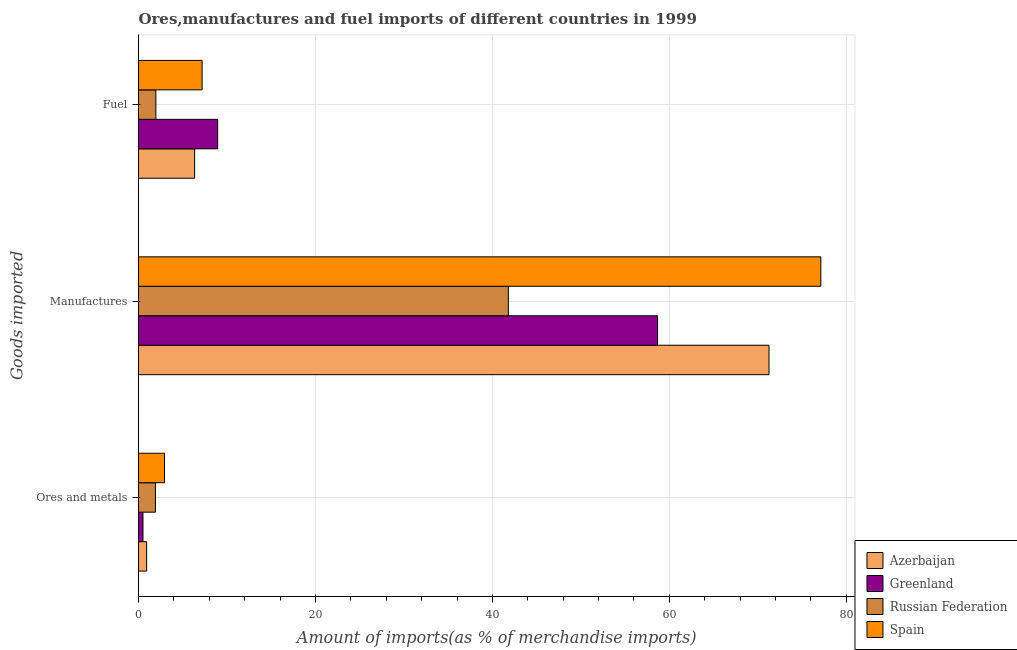How many bars are there on the 3rd tick from the top?
Your answer should be very brief. 4. What is the label of the 2nd group of bars from the top?
Your response must be concise. Manufactures. What is the percentage of fuel imports in Russian Federation?
Ensure brevity in your answer.  1.96. Across all countries, what is the maximum percentage of manufactures imports?
Keep it short and to the point. 77.12. Across all countries, what is the minimum percentage of manufactures imports?
Your answer should be very brief. 41.8. In which country was the percentage of fuel imports minimum?
Ensure brevity in your answer.  Russian Federation. What is the total percentage of fuel imports in the graph?
Offer a very short reply. 24.44. What is the difference between the percentage of fuel imports in Spain and that in Russian Federation?
Make the answer very short. 5.23. What is the difference between the percentage of fuel imports in Greenland and the percentage of ores and metals imports in Azerbaijan?
Your response must be concise. 8.03. What is the average percentage of fuel imports per country?
Your response must be concise. 6.11. What is the difference between the percentage of fuel imports and percentage of manufactures imports in Russian Federation?
Ensure brevity in your answer.  -39.84. In how many countries, is the percentage of fuel imports greater than 48 %?
Your answer should be compact. 0. What is the ratio of the percentage of manufactures imports in Russian Federation to that in Azerbaijan?
Your response must be concise. 0.59. Is the percentage of manufactures imports in Spain less than that in Greenland?
Your answer should be compact. No. Is the difference between the percentage of manufactures imports in Greenland and Russian Federation greater than the difference between the percentage of ores and metals imports in Greenland and Russian Federation?
Offer a very short reply. Yes. What is the difference between the highest and the second highest percentage of ores and metals imports?
Provide a succinct answer. 1.03. What is the difference between the highest and the lowest percentage of ores and metals imports?
Offer a very short reply. 2.44. Is the sum of the percentage of ores and metals imports in Azerbaijan and Greenland greater than the maximum percentage of manufactures imports across all countries?
Ensure brevity in your answer.  No. What does the 4th bar from the top in Manufactures represents?
Provide a short and direct response. Azerbaijan. What does the 1st bar from the bottom in Fuel represents?
Provide a short and direct response. Azerbaijan. Is it the case that in every country, the sum of the percentage of ores and metals imports and percentage of manufactures imports is greater than the percentage of fuel imports?
Provide a short and direct response. Yes. How many countries are there in the graph?
Your response must be concise. 4. Does the graph contain grids?
Your answer should be very brief. Yes. Where does the legend appear in the graph?
Provide a short and direct response. Bottom right. What is the title of the graph?
Your answer should be compact. Ores,manufactures and fuel imports of different countries in 1999. Does "Swaziland" appear as one of the legend labels in the graph?
Make the answer very short. No. What is the label or title of the X-axis?
Keep it short and to the point. Amount of imports(as % of merchandise imports). What is the label or title of the Y-axis?
Ensure brevity in your answer.  Goods imported. What is the Amount of imports(as % of merchandise imports) of Azerbaijan in Ores and metals?
Your response must be concise. 0.92. What is the Amount of imports(as % of merchandise imports) of Greenland in Ores and metals?
Make the answer very short. 0.5. What is the Amount of imports(as % of merchandise imports) of Russian Federation in Ores and metals?
Offer a terse response. 1.91. What is the Amount of imports(as % of merchandise imports) of Spain in Ores and metals?
Offer a terse response. 2.94. What is the Amount of imports(as % of merchandise imports) of Azerbaijan in Manufactures?
Provide a short and direct response. 71.26. What is the Amount of imports(as % of merchandise imports) in Greenland in Manufactures?
Keep it short and to the point. 58.67. What is the Amount of imports(as % of merchandise imports) of Russian Federation in Manufactures?
Keep it short and to the point. 41.8. What is the Amount of imports(as % of merchandise imports) of Spain in Manufactures?
Your response must be concise. 77.12. What is the Amount of imports(as % of merchandise imports) of Azerbaijan in Fuel?
Ensure brevity in your answer.  6.34. What is the Amount of imports(as % of merchandise imports) in Greenland in Fuel?
Give a very brief answer. 8.95. What is the Amount of imports(as % of merchandise imports) of Russian Federation in Fuel?
Your response must be concise. 1.96. What is the Amount of imports(as % of merchandise imports) of Spain in Fuel?
Make the answer very short. 7.19. Across all Goods imported, what is the maximum Amount of imports(as % of merchandise imports) of Azerbaijan?
Your response must be concise. 71.26. Across all Goods imported, what is the maximum Amount of imports(as % of merchandise imports) in Greenland?
Your answer should be very brief. 58.67. Across all Goods imported, what is the maximum Amount of imports(as % of merchandise imports) of Russian Federation?
Keep it short and to the point. 41.8. Across all Goods imported, what is the maximum Amount of imports(as % of merchandise imports) of Spain?
Provide a succinct answer. 77.12. Across all Goods imported, what is the minimum Amount of imports(as % of merchandise imports) in Azerbaijan?
Your answer should be very brief. 0.92. Across all Goods imported, what is the minimum Amount of imports(as % of merchandise imports) in Greenland?
Offer a terse response. 0.5. Across all Goods imported, what is the minimum Amount of imports(as % of merchandise imports) of Russian Federation?
Provide a short and direct response. 1.91. Across all Goods imported, what is the minimum Amount of imports(as % of merchandise imports) of Spain?
Your answer should be very brief. 2.94. What is the total Amount of imports(as % of merchandise imports) of Azerbaijan in the graph?
Ensure brevity in your answer.  78.52. What is the total Amount of imports(as % of merchandise imports) of Greenland in the graph?
Offer a very short reply. 68.12. What is the total Amount of imports(as % of merchandise imports) of Russian Federation in the graph?
Offer a terse response. 45.68. What is the total Amount of imports(as % of merchandise imports) in Spain in the graph?
Provide a succinct answer. 87.25. What is the difference between the Amount of imports(as % of merchandise imports) of Azerbaijan in Ores and metals and that in Manufactures?
Give a very brief answer. -70.34. What is the difference between the Amount of imports(as % of merchandise imports) in Greenland in Ores and metals and that in Manufactures?
Your response must be concise. -58.16. What is the difference between the Amount of imports(as % of merchandise imports) of Russian Federation in Ores and metals and that in Manufactures?
Your answer should be compact. -39.89. What is the difference between the Amount of imports(as % of merchandise imports) in Spain in Ores and metals and that in Manufactures?
Give a very brief answer. -74.18. What is the difference between the Amount of imports(as % of merchandise imports) in Azerbaijan in Ores and metals and that in Fuel?
Your answer should be compact. -5.42. What is the difference between the Amount of imports(as % of merchandise imports) in Greenland in Ores and metals and that in Fuel?
Your answer should be very brief. -8.44. What is the difference between the Amount of imports(as % of merchandise imports) in Russian Federation in Ores and metals and that in Fuel?
Provide a succinct answer. -0.05. What is the difference between the Amount of imports(as % of merchandise imports) in Spain in Ores and metals and that in Fuel?
Make the answer very short. -4.25. What is the difference between the Amount of imports(as % of merchandise imports) in Azerbaijan in Manufactures and that in Fuel?
Your response must be concise. 64.92. What is the difference between the Amount of imports(as % of merchandise imports) of Greenland in Manufactures and that in Fuel?
Provide a short and direct response. 49.72. What is the difference between the Amount of imports(as % of merchandise imports) in Russian Federation in Manufactures and that in Fuel?
Offer a terse response. 39.84. What is the difference between the Amount of imports(as % of merchandise imports) of Spain in Manufactures and that in Fuel?
Offer a very short reply. 69.93. What is the difference between the Amount of imports(as % of merchandise imports) in Azerbaijan in Ores and metals and the Amount of imports(as % of merchandise imports) in Greenland in Manufactures?
Provide a short and direct response. -57.75. What is the difference between the Amount of imports(as % of merchandise imports) of Azerbaijan in Ores and metals and the Amount of imports(as % of merchandise imports) of Russian Federation in Manufactures?
Your answer should be compact. -40.88. What is the difference between the Amount of imports(as % of merchandise imports) in Azerbaijan in Ores and metals and the Amount of imports(as % of merchandise imports) in Spain in Manufactures?
Provide a succinct answer. -76.2. What is the difference between the Amount of imports(as % of merchandise imports) of Greenland in Ores and metals and the Amount of imports(as % of merchandise imports) of Russian Federation in Manufactures?
Your answer should be very brief. -41.3. What is the difference between the Amount of imports(as % of merchandise imports) of Greenland in Ores and metals and the Amount of imports(as % of merchandise imports) of Spain in Manufactures?
Provide a short and direct response. -76.62. What is the difference between the Amount of imports(as % of merchandise imports) of Russian Federation in Ores and metals and the Amount of imports(as % of merchandise imports) of Spain in Manufactures?
Your answer should be very brief. -75.21. What is the difference between the Amount of imports(as % of merchandise imports) in Azerbaijan in Ores and metals and the Amount of imports(as % of merchandise imports) in Greenland in Fuel?
Your answer should be compact. -8.03. What is the difference between the Amount of imports(as % of merchandise imports) in Azerbaijan in Ores and metals and the Amount of imports(as % of merchandise imports) in Russian Federation in Fuel?
Ensure brevity in your answer.  -1.04. What is the difference between the Amount of imports(as % of merchandise imports) in Azerbaijan in Ores and metals and the Amount of imports(as % of merchandise imports) in Spain in Fuel?
Give a very brief answer. -6.27. What is the difference between the Amount of imports(as % of merchandise imports) of Greenland in Ores and metals and the Amount of imports(as % of merchandise imports) of Russian Federation in Fuel?
Your response must be concise. -1.46. What is the difference between the Amount of imports(as % of merchandise imports) in Greenland in Ores and metals and the Amount of imports(as % of merchandise imports) in Spain in Fuel?
Your answer should be compact. -6.68. What is the difference between the Amount of imports(as % of merchandise imports) in Russian Federation in Ores and metals and the Amount of imports(as % of merchandise imports) in Spain in Fuel?
Provide a succinct answer. -5.28. What is the difference between the Amount of imports(as % of merchandise imports) of Azerbaijan in Manufactures and the Amount of imports(as % of merchandise imports) of Greenland in Fuel?
Your answer should be compact. 62.32. What is the difference between the Amount of imports(as % of merchandise imports) in Azerbaijan in Manufactures and the Amount of imports(as % of merchandise imports) in Russian Federation in Fuel?
Ensure brevity in your answer.  69.3. What is the difference between the Amount of imports(as % of merchandise imports) in Azerbaijan in Manufactures and the Amount of imports(as % of merchandise imports) in Spain in Fuel?
Your answer should be very brief. 64.07. What is the difference between the Amount of imports(as % of merchandise imports) in Greenland in Manufactures and the Amount of imports(as % of merchandise imports) in Russian Federation in Fuel?
Ensure brevity in your answer.  56.7. What is the difference between the Amount of imports(as % of merchandise imports) of Greenland in Manufactures and the Amount of imports(as % of merchandise imports) of Spain in Fuel?
Keep it short and to the point. 51.48. What is the difference between the Amount of imports(as % of merchandise imports) in Russian Federation in Manufactures and the Amount of imports(as % of merchandise imports) in Spain in Fuel?
Offer a very short reply. 34.61. What is the average Amount of imports(as % of merchandise imports) in Azerbaijan per Goods imported?
Your answer should be compact. 26.17. What is the average Amount of imports(as % of merchandise imports) of Greenland per Goods imported?
Provide a succinct answer. 22.71. What is the average Amount of imports(as % of merchandise imports) of Russian Federation per Goods imported?
Your answer should be very brief. 15.23. What is the average Amount of imports(as % of merchandise imports) in Spain per Goods imported?
Provide a succinct answer. 29.08. What is the difference between the Amount of imports(as % of merchandise imports) in Azerbaijan and Amount of imports(as % of merchandise imports) in Greenland in Ores and metals?
Offer a terse response. 0.42. What is the difference between the Amount of imports(as % of merchandise imports) of Azerbaijan and Amount of imports(as % of merchandise imports) of Russian Federation in Ores and metals?
Make the answer very short. -0.99. What is the difference between the Amount of imports(as % of merchandise imports) in Azerbaijan and Amount of imports(as % of merchandise imports) in Spain in Ores and metals?
Your answer should be very brief. -2.02. What is the difference between the Amount of imports(as % of merchandise imports) of Greenland and Amount of imports(as % of merchandise imports) of Russian Federation in Ores and metals?
Provide a short and direct response. -1.41. What is the difference between the Amount of imports(as % of merchandise imports) of Greenland and Amount of imports(as % of merchandise imports) of Spain in Ores and metals?
Give a very brief answer. -2.44. What is the difference between the Amount of imports(as % of merchandise imports) in Russian Federation and Amount of imports(as % of merchandise imports) in Spain in Ores and metals?
Ensure brevity in your answer.  -1.03. What is the difference between the Amount of imports(as % of merchandise imports) of Azerbaijan and Amount of imports(as % of merchandise imports) of Greenland in Manufactures?
Offer a very short reply. 12.6. What is the difference between the Amount of imports(as % of merchandise imports) of Azerbaijan and Amount of imports(as % of merchandise imports) of Russian Federation in Manufactures?
Provide a succinct answer. 29.46. What is the difference between the Amount of imports(as % of merchandise imports) in Azerbaijan and Amount of imports(as % of merchandise imports) in Spain in Manufactures?
Offer a very short reply. -5.86. What is the difference between the Amount of imports(as % of merchandise imports) of Greenland and Amount of imports(as % of merchandise imports) of Russian Federation in Manufactures?
Your response must be concise. 16.86. What is the difference between the Amount of imports(as % of merchandise imports) in Greenland and Amount of imports(as % of merchandise imports) in Spain in Manufactures?
Offer a terse response. -18.46. What is the difference between the Amount of imports(as % of merchandise imports) in Russian Federation and Amount of imports(as % of merchandise imports) in Spain in Manufactures?
Provide a succinct answer. -35.32. What is the difference between the Amount of imports(as % of merchandise imports) of Azerbaijan and Amount of imports(as % of merchandise imports) of Greenland in Fuel?
Provide a succinct answer. -2.61. What is the difference between the Amount of imports(as % of merchandise imports) in Azerbaijan and Amount of imports(as % of merchandise imports) in Russian Federation in Fuel?
Your answer should be compact. 4.38. What is the difference between the Amount of imports(as % of merchandise imports) of Azerbaijan and Amount of imports(as % of merchandise imports) of Spain in Fuel?
Your answer should be compact. -0.85. What is the difference between the Amount of imports(as % of merchandise imports) in Greenland and Amount of imports(as % of merchandise imports) in Russian Federation in Fuel?
Your answer should be compact. 6.98. What is the difference between the Amount of imports(as % of merchandise imports) in Greenland and Amount of imports(as % of merchandise imports) in Spain in Fuel?
Give a very brief answer. 1.76. What is the difference between the Amount of imports(as % of merchandise imports) of Russian Federation and Amount of imports(as % of merchandise imports) of Spain in Fuel?
Keep it short and to the point. -5.23. What is the ratio of the Amount of imports(as % of merchandise imports) of Azerbaijan in Ores and metals to that in Manufactures?
Give a very brief answer. 0.01. What is the ratio of the Amount of imports(as % of merchandise imports) of Greenland in Ores and metals to that in Manufactures?
Provide a short and direct response. 0.01. What is the ratio of the Amount of imports(as % of merchandise imports) in Russian Federation in Ores and metals to that in Manufactures?
Your answer should be compact. 0.05. What is the ratio of the Amount of imports(as % of merchandise imports) of Spain in Ores and metals to that in Manufactures?
Your answer should be very brief. 0.04. What is the ratio of the Amount of imports(as % of merchandise imports) of Azerbaijan in Ores and metals to that in Fuel?
Give a very brief answer. 0.14. What is the ratio of the Amount of imports(as % of merchandise imports) in Greenland in Ores and metals to that in Fuel?
Your response must be concise. 0.06. What is the ratio of the Amount of imports(as % of merchandise imports) in Russian Federation in Ores and metals to that in Fuel?
Your answer should be very brief. 0.97. What is the ratio of the Amount of imports(as % of merchandise imports) of Spain in Ores and metals to that in Fuel?
Your response must be concise. 0.41. What is the ratio of the Amount of imports(as % of merchandise imports) of Azerbaijan in Manufactures to that in Fuel?
Make the answer very short. 11.24. What is the ratio of the Amount of imports(as % of merchandise imports) of Greenland in Manufactures to that in Fuel?
Provide a succinct answer. 6.56. What is the ratio of the Amount of imports(as % of merchandise imports) of Russian Federation in Manufactures to that in Fuel?
Keep it short and to the point. 21.29. What is the ratio of the Amount of imports(as % of merchandise imports) in Spain in Manufactures to that in Fuel?
Offer a very short reply. 10.73. What is the difference between the highest and the second highest Amount of imports(as % of merchandise imports) in Azerbaijan?
Provide a succinct answer. 64.92. What is the difference between the highest and the second highest Amount of imports(as % of merchandise imports) in Greenland?
Ensure brevity in your answer.  49.72. What is the difference between the highest and the second highest Amount of imports(as % of merchandise imports) of Russian Federation?
Give a very brief answer. 39.84. What is the difference between the highest and the second highest Amount of imports(as % of merchandise imports) in Spain?
Offer a very short reply. 69.93. What is the difference between the highest and the lowest Amount of imports(as % of merchandise imports) of Azerbaijan?
Keep it short and to the point. 70.34. What is the difference between the highest and the lowest Amount of imports(as % of merchandise imports) of Greenland?
Your answer should be very brief. 58.16. What is the difference between the highest and the lowest Amount of imports(as % of merchandise imports) of Russian Federation?
Provide a short and direct response. 39.89. What is the difference between the highest and the lowest Amount of imports(as % of merchandise imports) of Spain?
Provide a succinct answer. 74.18. 